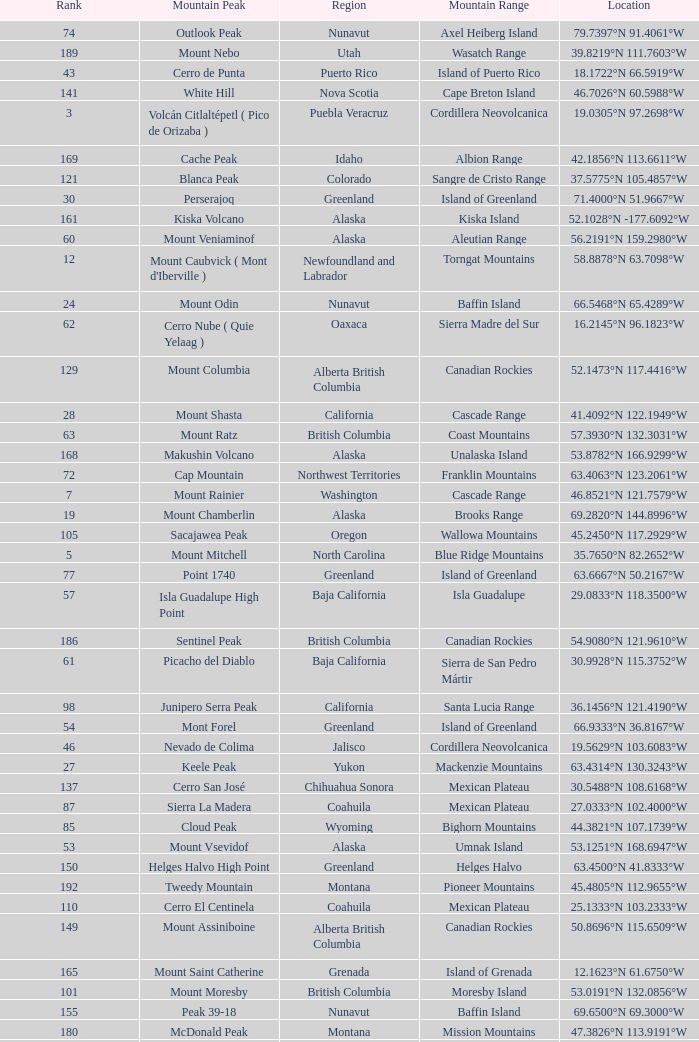Name the Region with a Mountain Peak of dillingham high point? Alaska. 